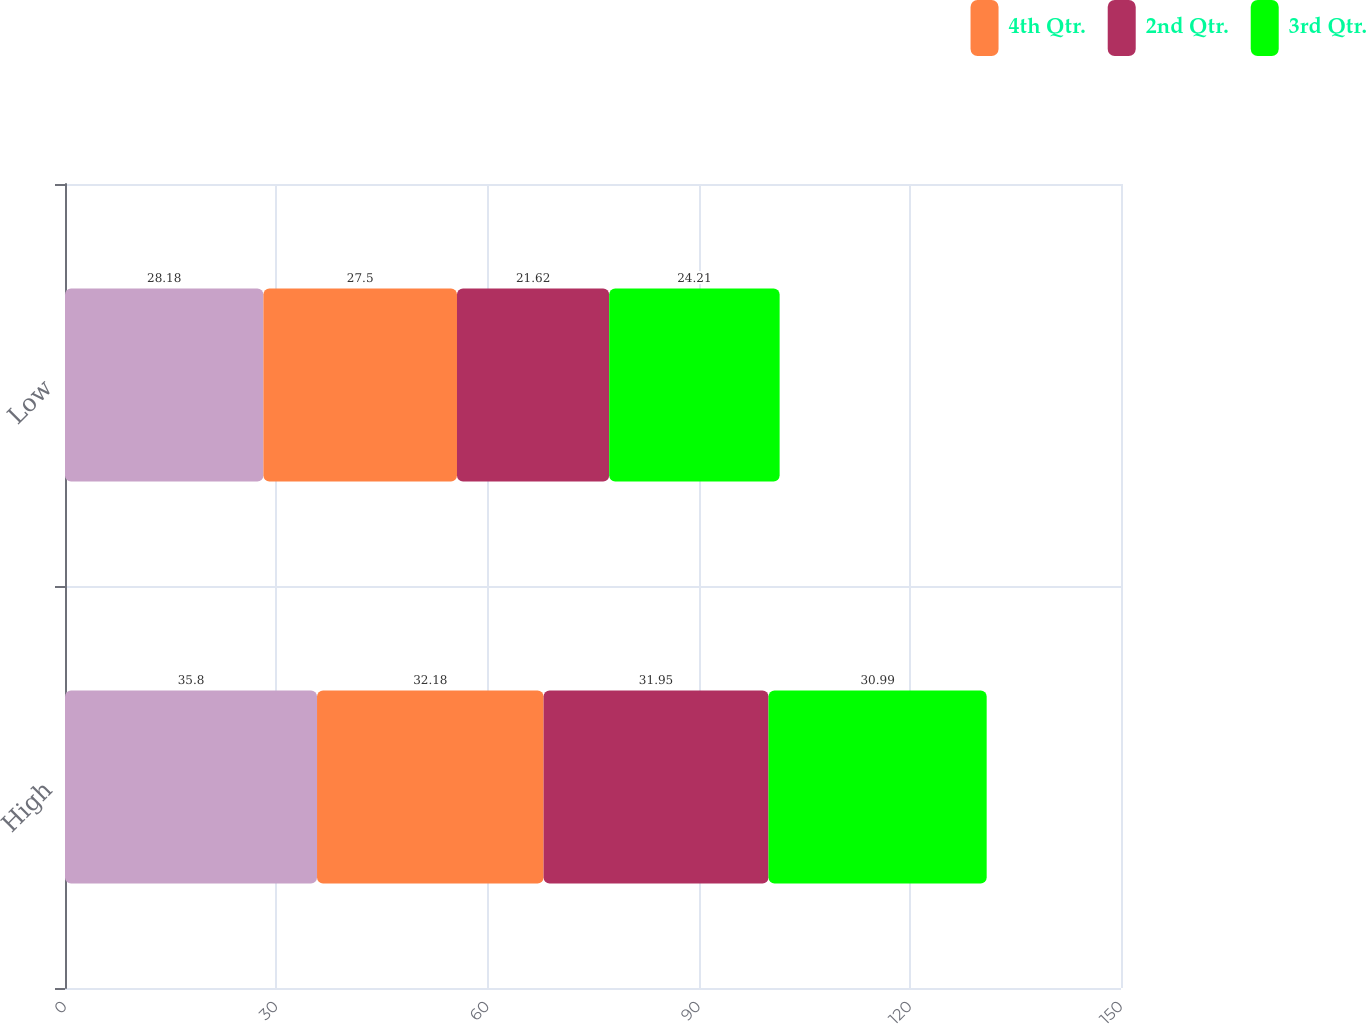Convert chart. <chart><loc_0><loc_0><loc_500><loc_500><stacked_bar_chart><ecel><fcel>High<fcel>Low<nl><fcel>nan<fcel>35.8<fcel>28.18<nl><fcel>4th Qtr.<fcel>32.18<fcel>27.5<nl><fcel>2nd Qtr.<fcel>31.95<fcel>21.62<nl><fcel>3rd Qtr.<fcel>30.99<fcel>24.21<nl></chart> 